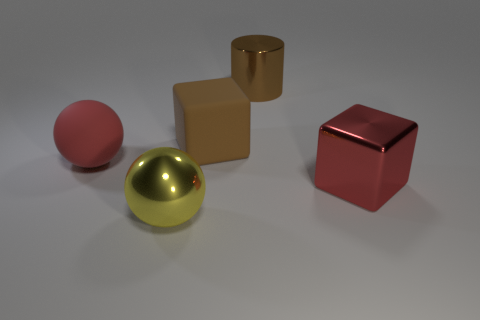There is a large brown object that is made of the same material as the red sphere; what is its shape?
Make the answer very short. Cube. What number of other objects are the same shape as the big brown shiny object?
Offer a terse response. 0. There is a object on the right side of the cylinder; does it have the same size as the big red rubber ball?
Give a very brief answer. Yes. Are there more big yellow shiny things in front of the rubber cube than small purple rubber cylinders?
Make the answer very short. Yes. There is a big sphere that is on the left side of the yellow sphere; what number of large red metal blocks are to the left of it?
Your response must be concise. 0. Are there fewer brown cylinders right of the large shiny cube than big matte objects?
Keep it short and to the point. Yes. Is there a big yellow shiny ball behind the big red object to the right of the large brown object that is left of the big shiny cylinder?
Offer a terse response. No. Is the material of the large cylinder the same as the block behind the big red matte object?
Your answer should be compact. No. The cube behind the sphere to the left of the shiny ball is what color?
Offer a very short reply. Brown. Are there any big balls of the same color as the big metallic cylinder?
Ensure brevity in your answer.  No. 